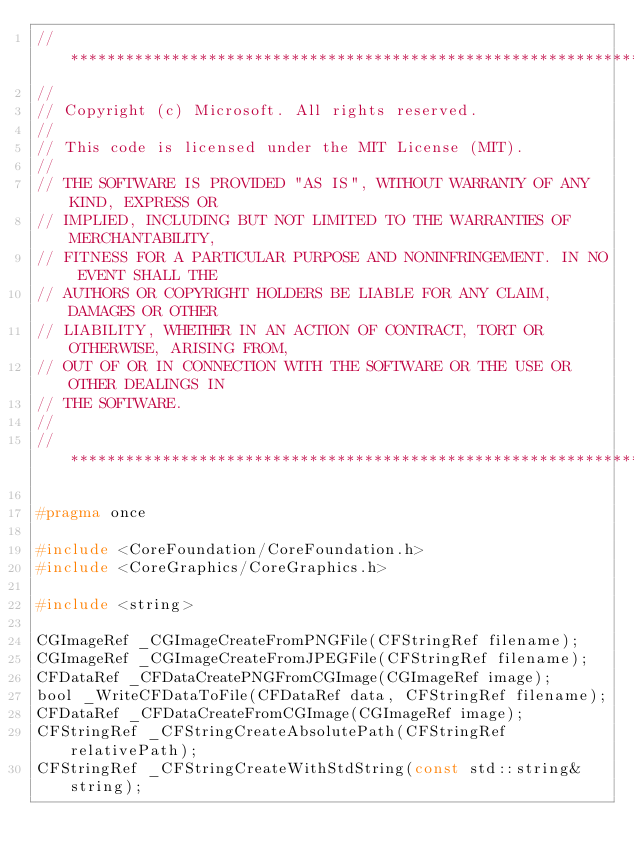<code> <loc_0><loc_0><loc_500><loc_500><_C_>//******************************************************************************
//
// Copyright (c) Microsoft. All rights reserved.
//
// This code is licensed under the MIT License (MIT).
//
// THE SOFTWARE IS PROVIDED "AS IS", WITHOUT WARRANTY OF ANY KIND, EXPRESS OR
// IMPLIED, INCLUDING BUT NOT LIMITED TO THE WARRANTIES OF MERCHANTABILITY,
// FITNESS FOR A PARTICULAR PURPOSE AND NONINFRINGEMENT. IN NO EVENT SHALL THE
// AUTHORS OR COPYRIGHT HOLDERS BE LIABLE FOR ANY CLAIM, DAMAGES OR OTHER
// LIABILITY, WHETHER IN AN ACTION OF CONTRACT, TORT OR OTHERWISE, ARISING FROM,
// OUT OF OR IN CONNECTION WITH THE SOFTWARE OR THE USE OR OTHER DEALINGS IN
// THE SOFTWARE.
//
//******************************************************************************

#pragma once

#include <CoreFoundation/CoreFoundation.h>
#include <CoreGraphics/CoreGraphics.h>

#include <string>

CGImageRef _CGImageCreateFromPNGFile(CFStringRef filename);
CGImageRef _CGImageCreateFromJPEGFile(CFStringRef filename);
CFDataRef _CFDataCreatePNGFromCGImage(CGImageRef image);
bool _WriteCFDataToFile(CFDataRef data, CFStringRef filename);
CFDataRef _CFDataCreateFromCGImage(CGImageRef image);
CFStringRef _CFStringCreateAbsolutePath(CFStringRef relativePath);
CFStringRef _CFStringCreateWithStdString(const std::string& string);
</code> 